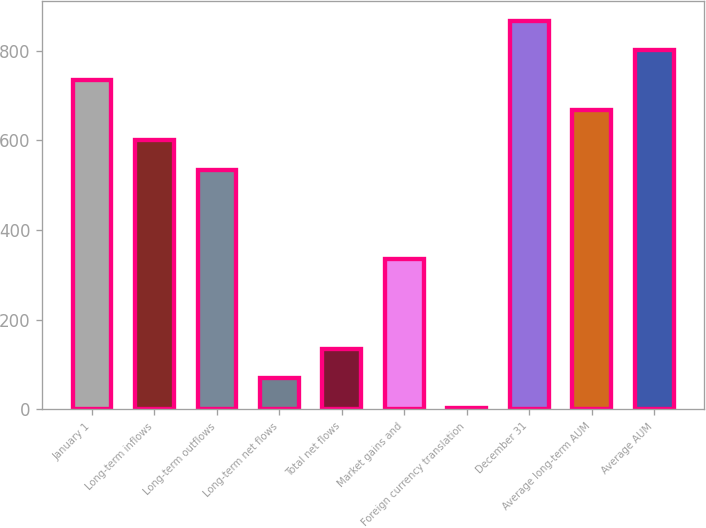Convert chart to OTSL. <chart><loc_0><loc_0><loc_500><loc_500><bar_chart><fcel>January 1<fcel>Long-term inflows<fcel>Long-term outflows<fcel>Long-term net flows<fcel>Total net flows<fcel>Market gains and<fcel>Foreign currency translation<fcel>December 31<fcel>Average long-term AUM<fcel>Average AUM<nl><fcel>733.86<fcel>600.94<fcel>534.48<fcel>69.26<fcel>135.72<fcel>335.1<fcel>2.8<fcel>866.78<fcel>667.4<fcel>800.32<nl></chart> 